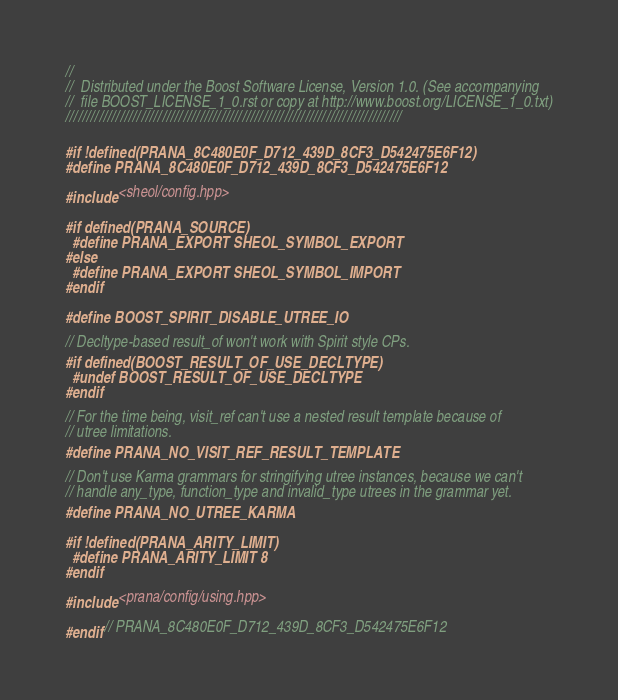Convert code to text. <code><loc_0><loc_0><loc_500><loc_500><_C++_>//
//  Distributed under the Boost Software License, Version 1.0. (See accompanying
//  file BOOST_LICENSE_1_0.rst or copy at http://www.boost.org/LICENSE_1_0.txt)
////////////////////////////////////////////////////////////////////////////////

#if !defined(PRANA_8C480E0F_D712_439D_8CF3_D542475E6F12)
#define PRANA_8C480E0F_D712_439D_8CF3_D542475E6F12

#include <sheol/config.hpp>

#if defined(PRANA_SOURCE)
  #define PRANA_EXPORT SHEOL_SYMBOL_EXPORT
#else
  #define PRANA_EXPORT SHEOL_SYMBOL_IMPORT
#endif

#define BOOST_SPIRIT_DISABLE_UTREE_IO

// Decltype-based result_of won't work with Spirit style CPs.
#if defined(BOOST_RESULT_OF_USE_DECLTYPE)
  #undef BOOST_RESULT_OF_USE_DECLTYPE
#endif

// For the time being, visit_ref can't use a nested result template because of
// utree limitations.
#define PRANA_NO_VISIT_REF_RESULT_TEMPLATE

// Don't use Karma grammars for stringifying utree instances, because we can't
// handle any_type, function_type and invalid_type utrees in the grammar yet.
#define PRANA_NO_UTREE_KARMA

#if !defined(PRANA_ARITY_LIMIT)
  #define PRANA_ARITY_LIMIT 8
#endif

#include <prana/config/using.hpp>

#endif // PRANA_8C480E0F_D712_439D_8CF3_D542475E6F12

</code> 